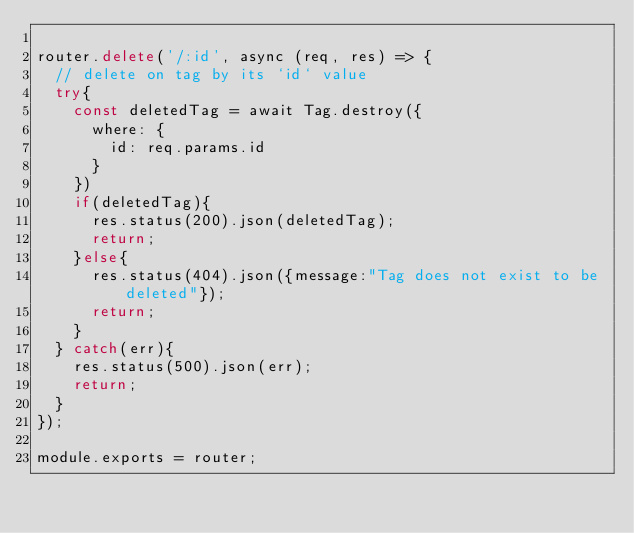<code> <loc_0><loc_0><loc_500><loc_500><_JavaScript_>
router.delete('/:id', async (req, res) => {
  // delete on tag by its `id` value
  try{
    const deletedTag = await Tag.destroy({
      where: {
        id: req.params.id
      }
    })
    if(deletedTag){
      res.status(200).json(deletedTag);
      return;
    }else{
      res.status(404).json({message:"Tag does not exist to be deleted"});
      return;
    }
  } catch(err){
    res.status(500).json(err);
    return;
  }
});

module.exports = router;
</code> 